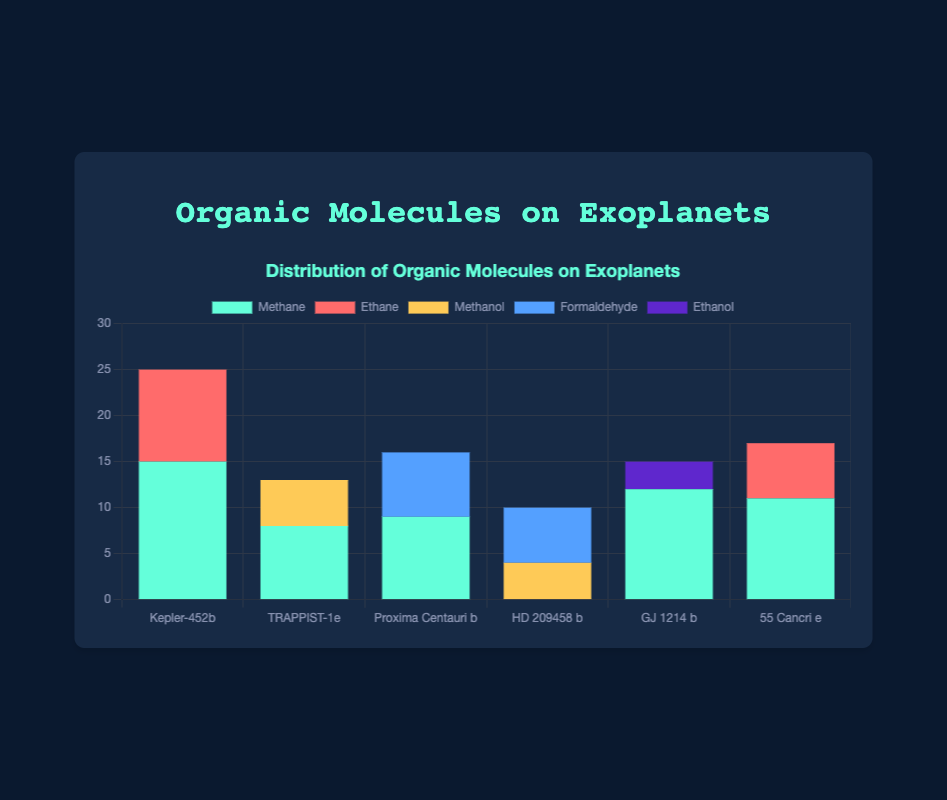Which exoplanet has the highest quantity of methane detected? Kepler-452b has the highest quantity of methane detected as indicated by the tallest green bar in the stacked bar chart for this molecule, which is 15.
Answer: Kepler-452b Among the detection methods used, which one detected the highest quantity of organic molecules on Proxima Centauri b? The Transmission Spectroscopy method detected the highest quantity of organic molecules on Proxima Centauri b. Adding the quantities of methane detected via Transmission Spectroscopy and formaldehyde detected via Direct Imaging, we get 9 and 7 respectively, and 9 is greater.
Answer: Transmission Spectroscopy What is the total quantity of organic molecules detected on HD 209458 b via Transmission Spectroscopy? The total quantity detected on HD 209458 b via Transmission Spectroscopy is calculated by adding the quantities of formaldehyde detected which is 6. There are no other molecules detected via this method for this exoplanet.
Answer: 6 Which molecule is the most frequently detected across all exoplanets and detection methods? By scanning the height of bars corresponding to each molecule across all exoplanets, methane appears most frequently with its presence on Kepler-452b, TRAPPIST-1e, Proxima Centauri b, GJ 1214 b, and 55 Cancri e. Methane tops with higher quantities.
Answer: Methane Comparing Ethanol on GJ 1214 b and Methanol on TRAPPIST-1e, which one has a greater quantity and by how much? Ethanol on GJ 1214 b has a quantity of 3 while Methanol on TRAPPIST-1e has a quantity of 5. Subtracting 3 from 5 gives us the difference.
Answer: Methanol on TRAPPIST-1e by 2 What is the combined quantity of organic molecules detected using Direct Imaging on all exoplanets? Adding the quantities detected using Direct Imaging for TRAPPIST-1e (5), Proxima Centauri b (7), and GJ 1214 b (12), gives us a total.
Answer: 24 Which exoplanet has a more diverse range of detected organic molecules? By inspecting the chart, Kepler-452b shows the most diverse range with the detection of Methane and Ethane, implying the highest range of molecules as shown visually by different colored bars.
Answer: Kepler-452b What is the median quantity of methane detected across all exoplanets? Ordering quantities of methane detected (15, 9, 12, 8, 11), the median quantity is the middle number.
Answer: 11 Which detection method detected the greatest single quantity of any molecule, and what is the molecule? Transmission Spectroscopy detected the greatest single quantity of methane on Kepler-452b, indicated by the tallest green bar, which measures 15.
Answer: Transmission Spectroscopy, methane 